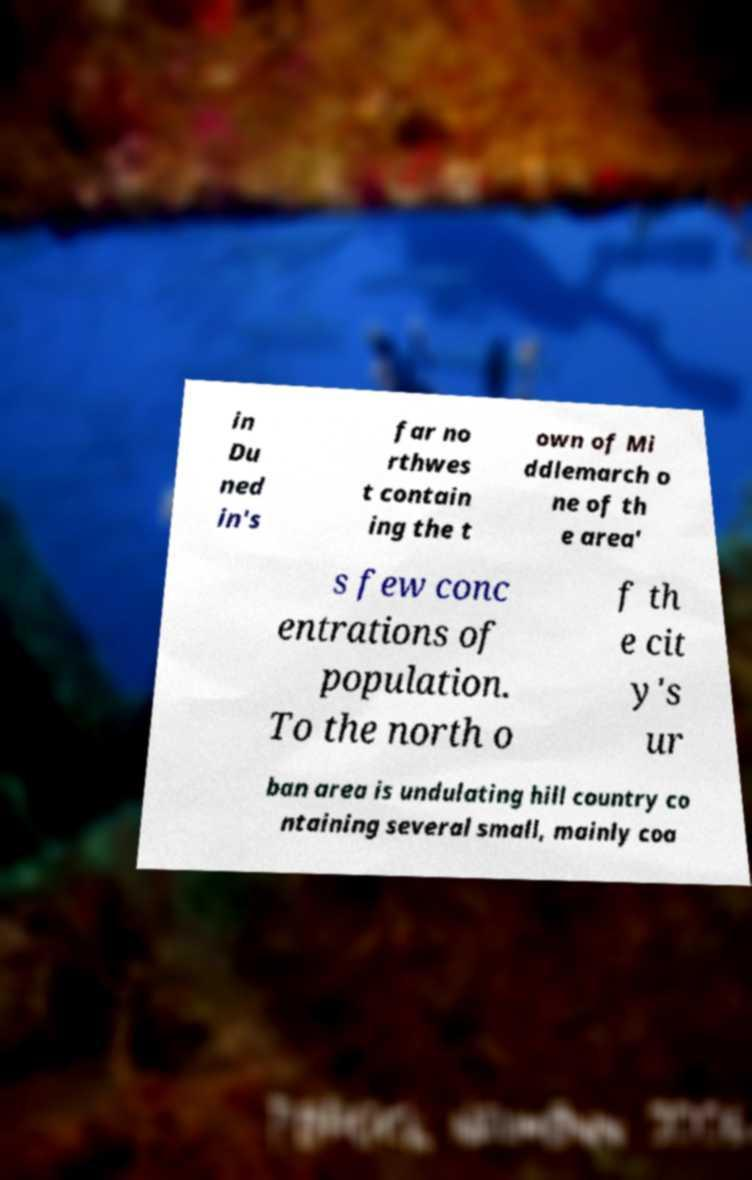What messages or text are displayed in this image? I need them in a readable, typed format. in Du ned in's far no rthwes t contain ing the t own of Mi ddlemarch o ne of th e area' s few conc entrations of population. To the north o f th e cit y's ur ban area is undulating hill country co ntaining several small, mainly coa 